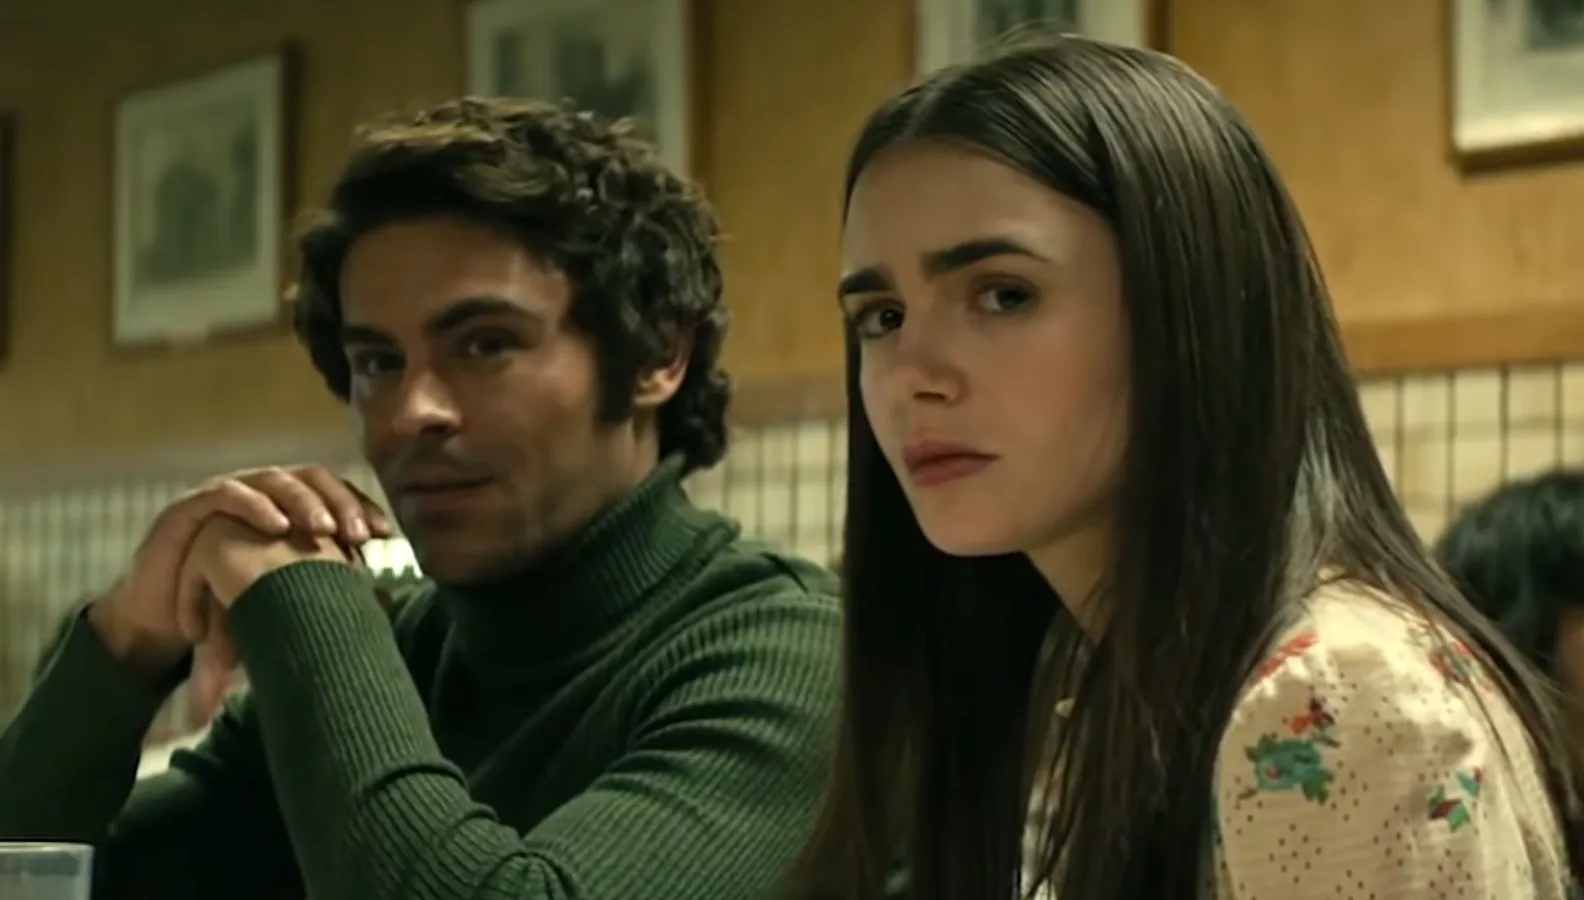Imagine this scene is from a romantic drama. Describe the dynamic between the characters. In a romantic drama, the scene captures a moment of vulnerability and emotional complexity. The man on the left, deeply contemplative, is perhaps sharing something personal and significant with the woman. His knitted brows and slight lean forward suggest he is earnest and engaged. The woman, absorbed in his words, mirrors this seriousness, indicating the weight of the conversation. Their close proximity and intense focus on the dialogue point to an intimate connection, perhaps navigating a crossroads in their relationship, filled with affection, yet charged with a delicate tension. 